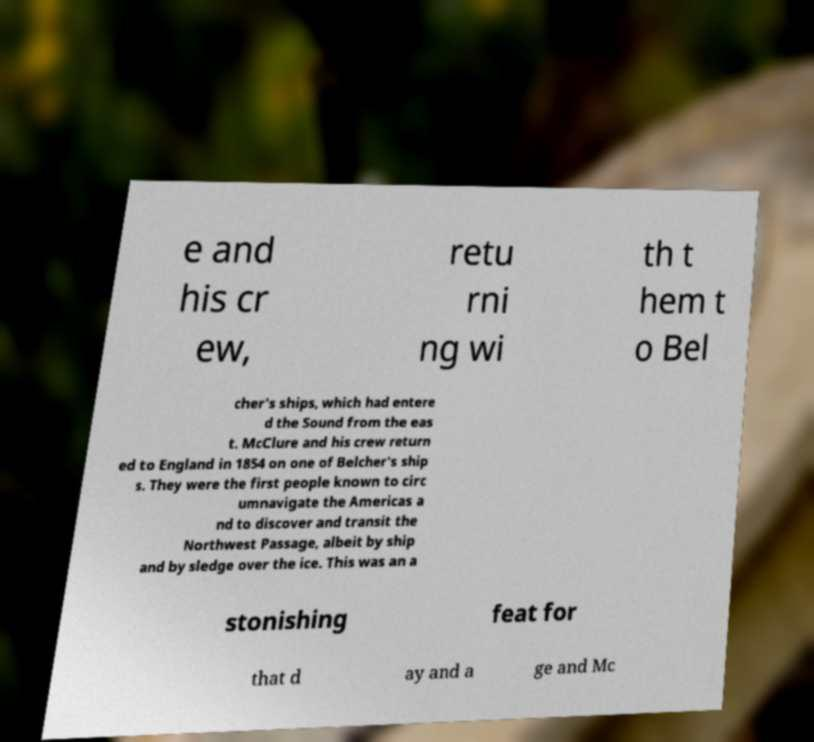Please identify and transcribe the text found in this image. e and his cr ew, retu rni ng wi th t hem t o Bel cher's ships, which had entere d the Sound from the eas t. McClure and his crew return ed to England in 1854 on one of Belcher's ship s. They were the first people known to circ umnavigate the Americas a nd to discover and transit the Northwest Passage, albeit by ship and by sledge over the ice. This was an a stonishing feat for that d ay and a ge and Mc 